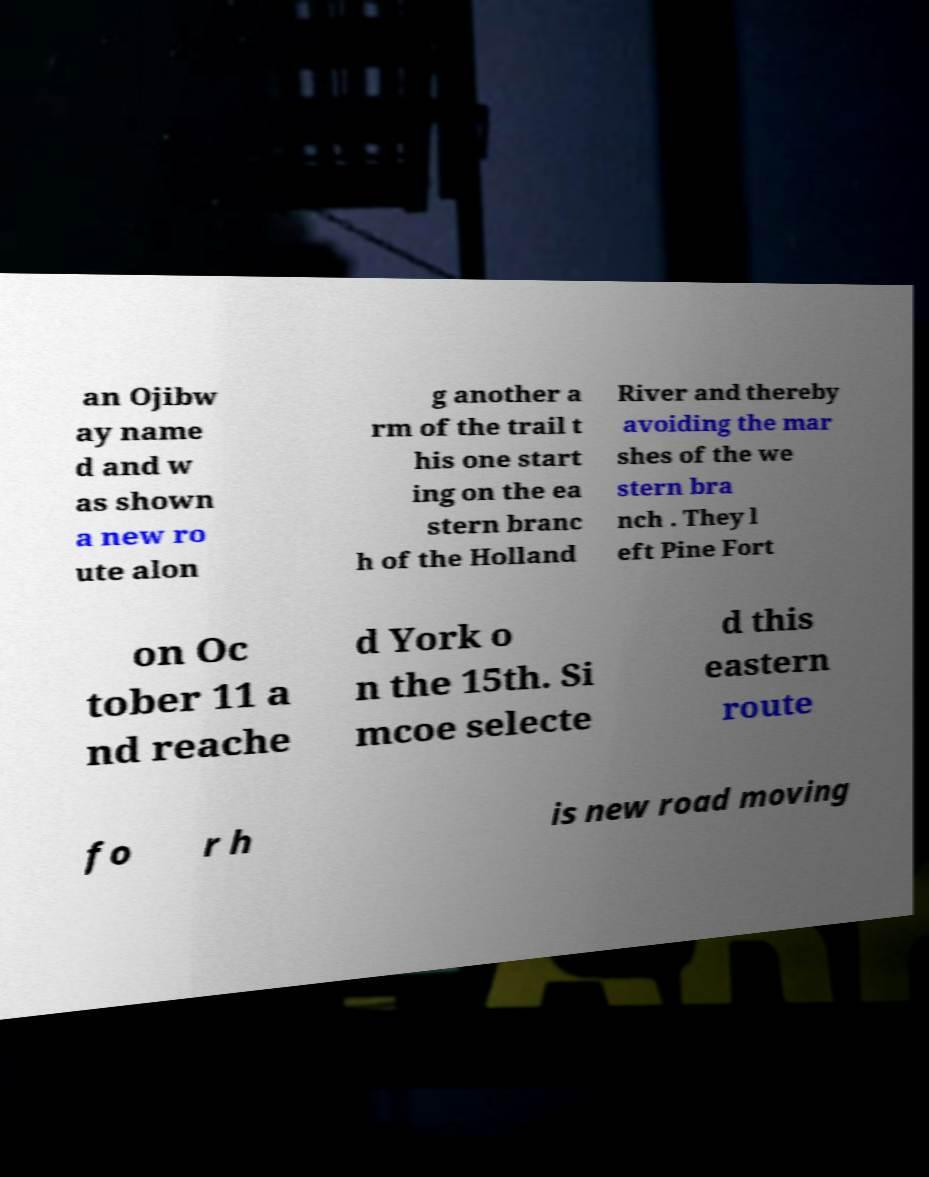Could you assist in decoding the text presented in this image and type it out clearly? an Ojibw ay name d and w as shown a new ro ute alon g another a rm of the trail t his one start ing on the ea stern branc h of the Holland River and thereby avoiding the mar shes of the we stern bra nch . They l eft Pine Fort on Oc tober 11 a nd reache d York o n the 15th. Si mcoe selecte d this eastern route fo r h is new road moving 